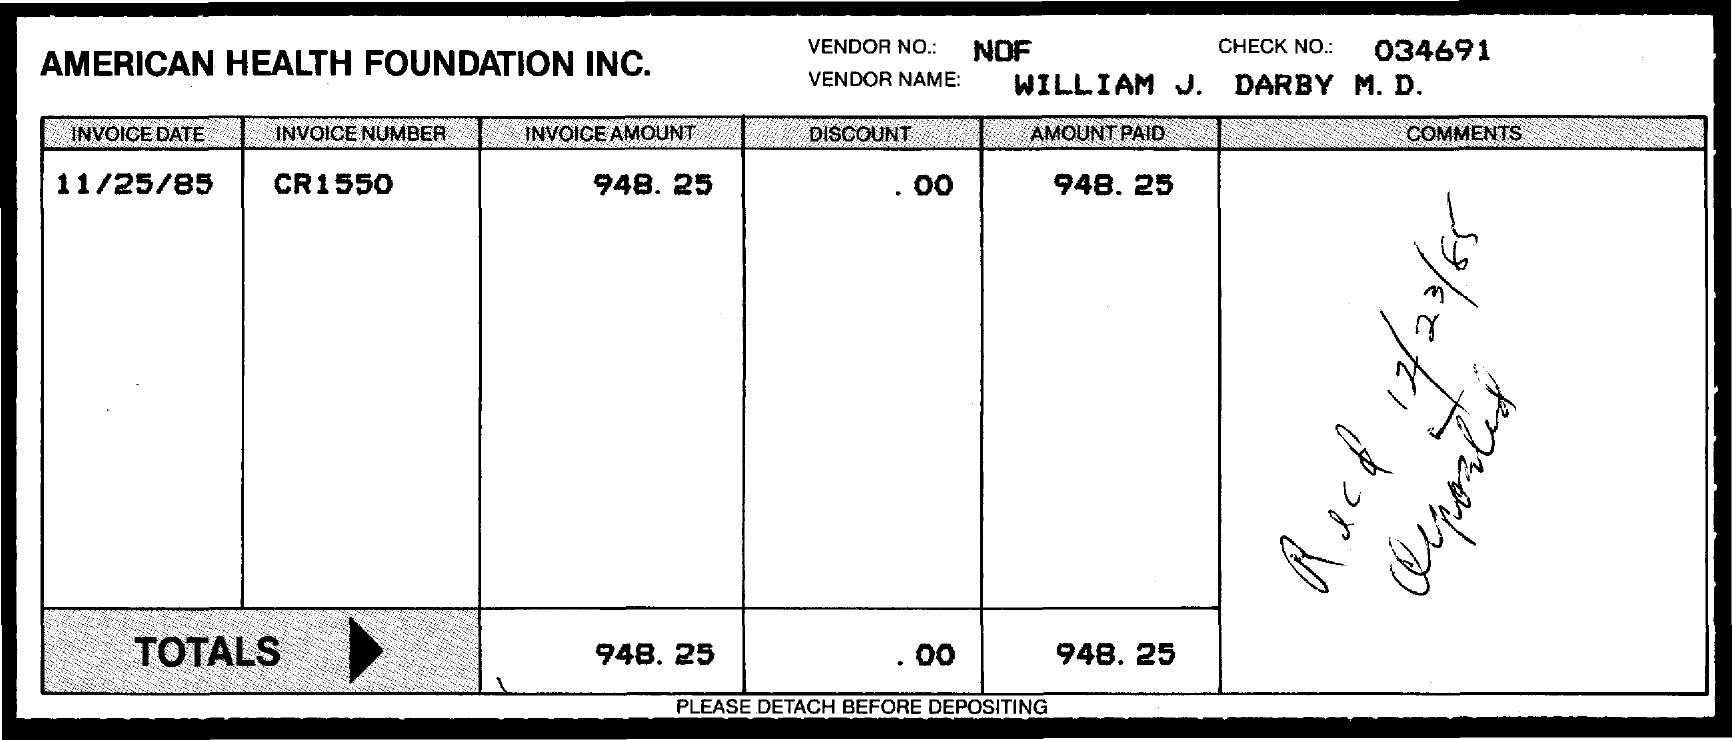Which company's invoice is given here?
Offer a very short reply. American health foundation inc. What is the vendor no given in the invoice?
Offer a very short reply. Nof. What is the check no given in the invoice?
Give a very brief answer. 034691. What is the vendor name mentioned in the invoice?
Your answer should be compact. WILLIAM J. DARBY M. D. What is the invoice date?
Your answer should be compact. 11/25/85. What is the invoice number given?
Make the answer very short. Cr1550. What is the invoice amount mentioned in the document?
Make the answer very short. 948.25. What is the received date of the invoice?
Provide a short and direct response. 12/23/85. 